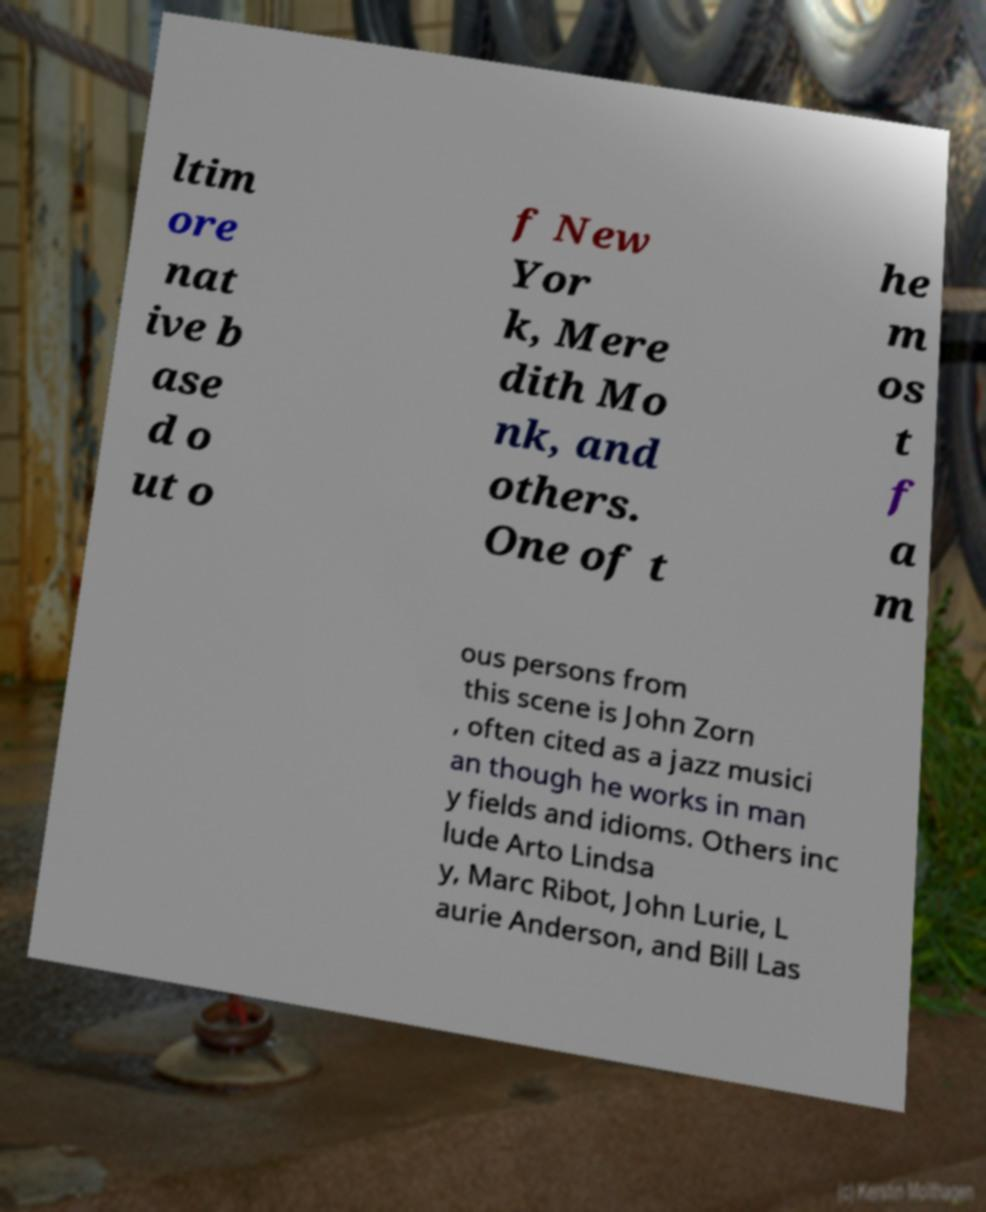Please identify and transcribe the text found in this image. ltim ore nat ive b ase d o ut o f New Yor k, Mere dith Mo nk, and others. One of t he m os t f a m ous persons from this scene is John Zorn , often cited as a jazz musici an though he works in man y fields and idioms. Others inc lude Arto Lindsa y, Marc Ribot, John Lurie, L aurie Anderson, and Bill Las 